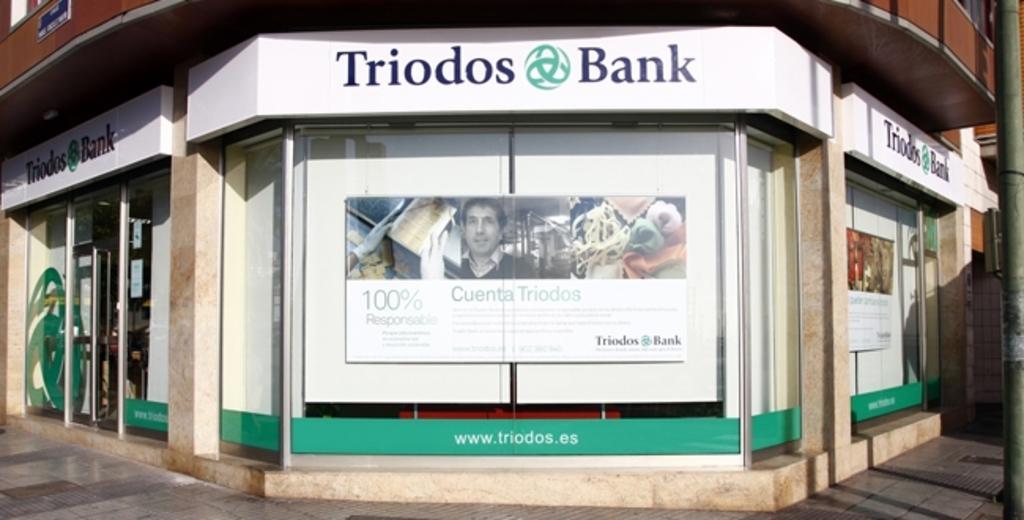In one or two sentences, can you explain what this image depicts? There is a poster in the center of the image and there is a door on the left side.''Triodos bank'' is written on the posters and there is a pole on the right side. 